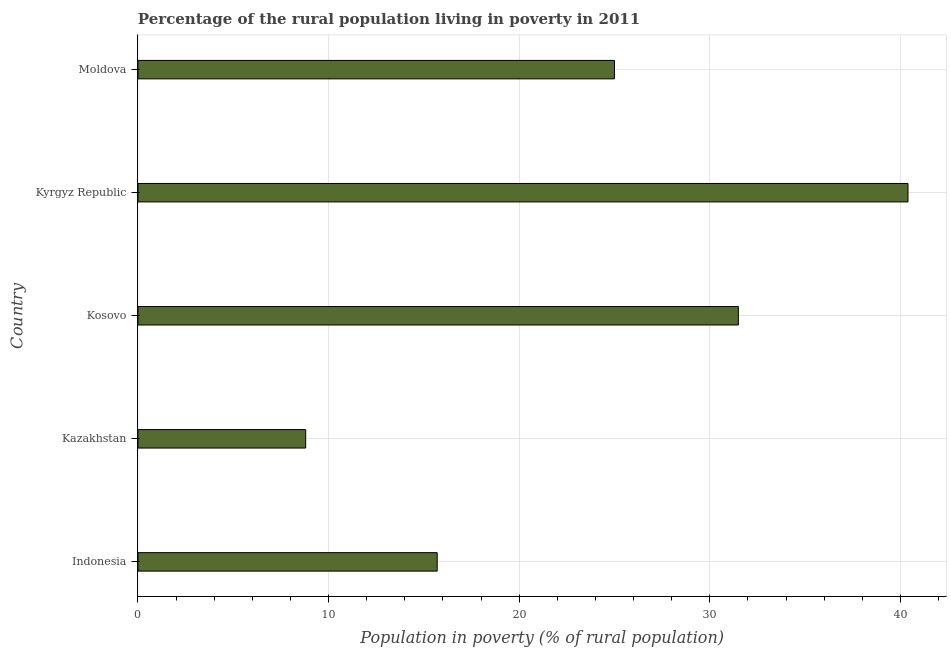Does the graph contain any zero values?
Keep it short and to the point. No. Does the graph contain grids?
Offer a very short reply. Yes. What is the title of the graph?
Give a very brief answer. Percentage of the rural population living in poverty in 2011. What is the label or title of the X-axis?
Give a very brief answer. Population in poverty (% of rural population). What is the percentage of rural population living below poverty line in Kyrgyz Republic?
Make the answer very short. 40.4. Across all countries, what is the maximum percentage of rural population living below poverty line?
Your answer should be compact. 40.4. Across all countries, what is the minimum percentage of rural population living below poverty line?
Ensure brevity in your answer.  8.8. In which country was the percentage of rural population living below poverty line maximum?
Ensure brevity in your answer.  Kyrgyz Republic. In which country was the percentage of rural population living below poverty line minimum?
Offer a very short reply. Kazakhstan. What is the sum of the percentage of rural population living below poverty line?
Your answer should be very brief. 121.4. What is the difference between the percentage of rural population living below poverty line in Kazakhstan and Kosovo?
Offer a terse response. -22.7. What is the average percentage of rural population living below poverty line per country?
Provide a succinct answer. 24.28. What is the median percentage of rural population living below poverty line?
Ensure brevity in your answer.  25. What is the ratio of the percentage of rural population living below poverty line in Indonesia to that in Kyrgyz Republic?
Offer a terse response. 0.39. Is the difference between the percentage of rural population living below poverty line in Indonesia and Kosovo greater than the difference between any two countries?
Offer a terse response. No. Is the sum of the percentage of rural population living below poverty line in Kazakhstan and Kosovo greater than the maximum percentage of rural population living below poverty line across all countries?
Provide a succinct answer. No. What is the difference between the highest and the lowest percentage of rural population living below poverty line?
Your answer should be compact. 31.6. Are the values on the major ticks of X-axis written in scientific E-notation?
Keep it short and to the point. No. What is the Population in poverty (% of rural population) in Kosovo?
Offer a terse response. 31.5. What is the Population in poverty (% of rural population) of Kyrgyz Republic?
Give a very brief answer. 40.4. What is the difference between the Population in poverty (% of rural population) in Indonesia and Kosovo?
Offer a very short reply. -15.8. What is the difference between the Population in poverty (% of rural population) in Indonesia and Kyrgyz Republic?
Give a very brief answer. -24.7. What is the difference between the Population in poverty (% of rural population) in Indonesia and Moldova?
Offer a very short reply. -9.3. What is the difference between the Population in poverty (% of rural population) in Kazakhstan and Kosovo?
Your answer should be compact. -22.7. What is the difference between the Population in poverty (% of rural population) in Kazakhstan and Kyrgyz Republic?
Ensure brevity in your answer.  -31.6. What is the difference between the Population in poverty (% of rural population) in Kazakhstan and Moldova?
Give a very brief answer. -16.2. What is the difference between the Population in poverty (% of rural population) in Kosovo and Kyrgyz Republic?
Make the answer very short. -8.9. What is the difference between the Population in poverty (% of rural population) in Kyrgyz Republic and Moldova?
Your response must be concise. 15.4. What is the ratio of the Population in poverty (% of rural population) in Indonesia to that in Kazakhstan?
Provide a succinct answer. 1.78. What is the ratio of the Population in poverty (% of rural population) in Indonesia to that in Kosovo?
Your answer should be compact. 0.5. What is the ratio of the Population in poverty (% of rural population) in Indonesia to that in Kyrgyz Republic?
Offer a terse response. 0.39. What is the ratio of the Population in poverty (% of rural population) in Indonesia to that in Moldova?
Keep it short and to the point. 0.63. What is the ratio of the Population in poverty (% of rural population) in Kazakhstan to that in Kosovo?
Make the answer very short. 0.28. What is the ratio of the Population in poverty (% of rural population) in Kazakhstan to that in Kyrgyz Republic?
Provide a short and direct response. 0.22. What is the ratio of the Population in poverty (% of rural population) in Kazakhstan to that in Moldova?
Provide a short and direct response. 0.35. What is the ratio of the Population in poverty (% of rural population) in Kosovo to that in Kyrgyz Republic?
Provide a short and direct response. 0.78. What is the ratio of the Population in poverty (% of rural population) in Kosovo to that in Moldova?
Your answer should be very brief. 1.26. What is the ratio of the Population in poverty (% of rural population) in Kyrgyz Republic to that in Moldova?
Your answer should be compact. 1.62. 